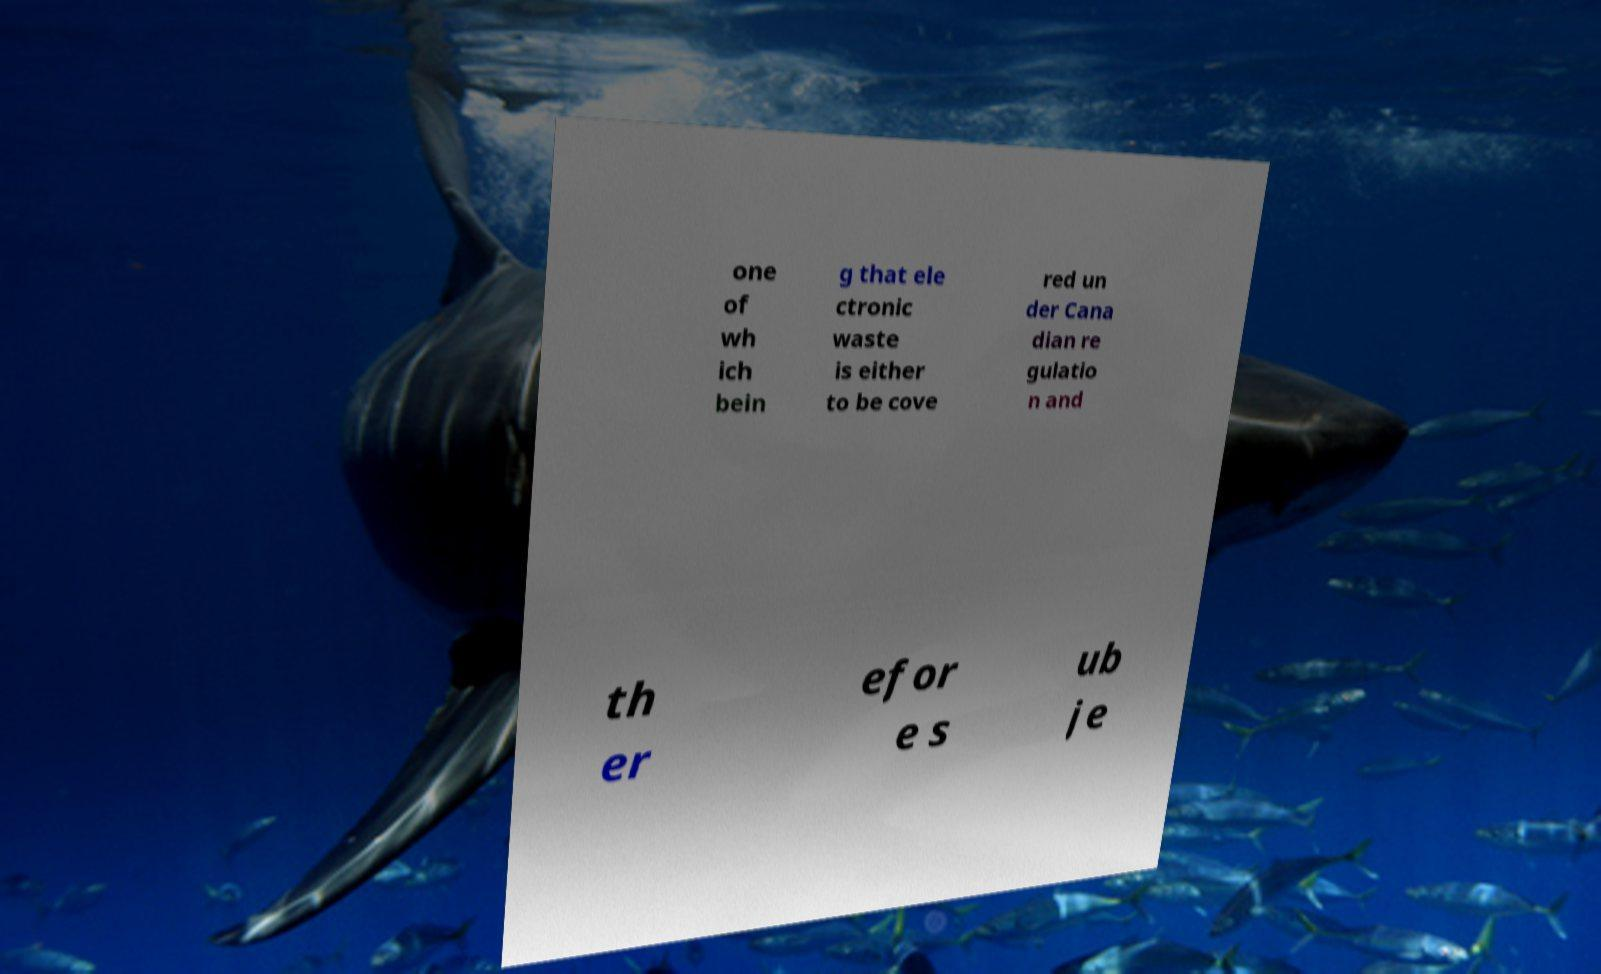Can you read and provide the text displayed in the image?This photo seems to have some interesting text. Can you extract and type it out for me? one of wh ich bein g that ele ctronic waste is either to be cove red un der Cana dian re gulatio n and th er efor e s ub je 